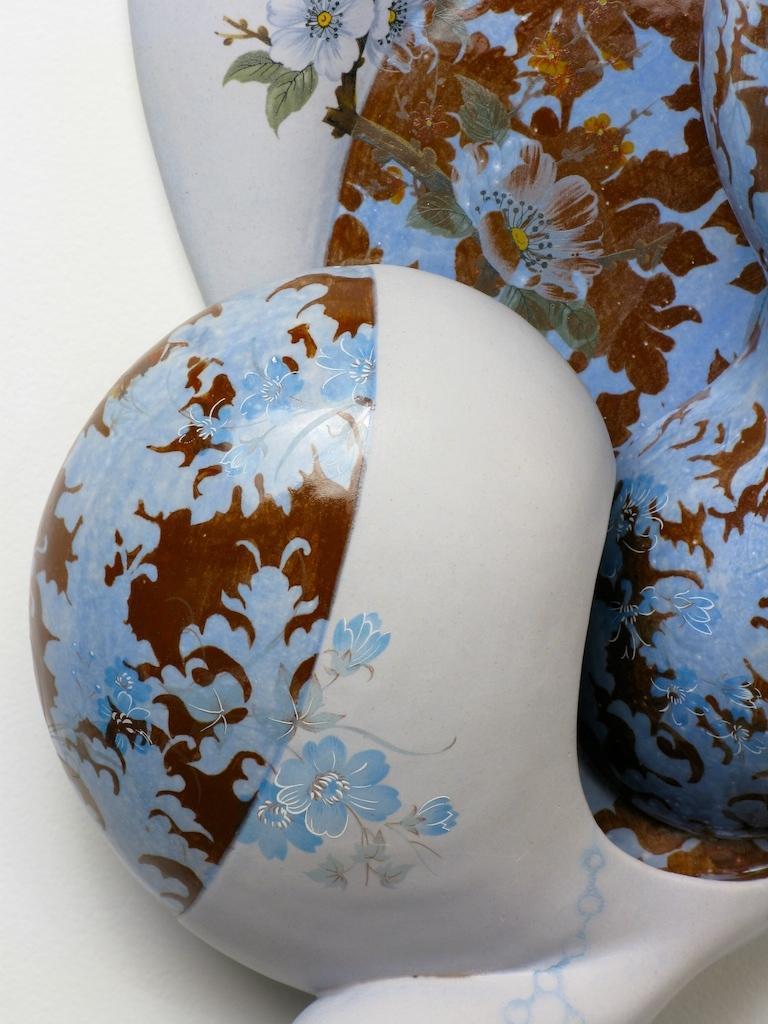Describe this image in one or two sentences. In this picture we can see designs on objects and in the background we can see white color. 